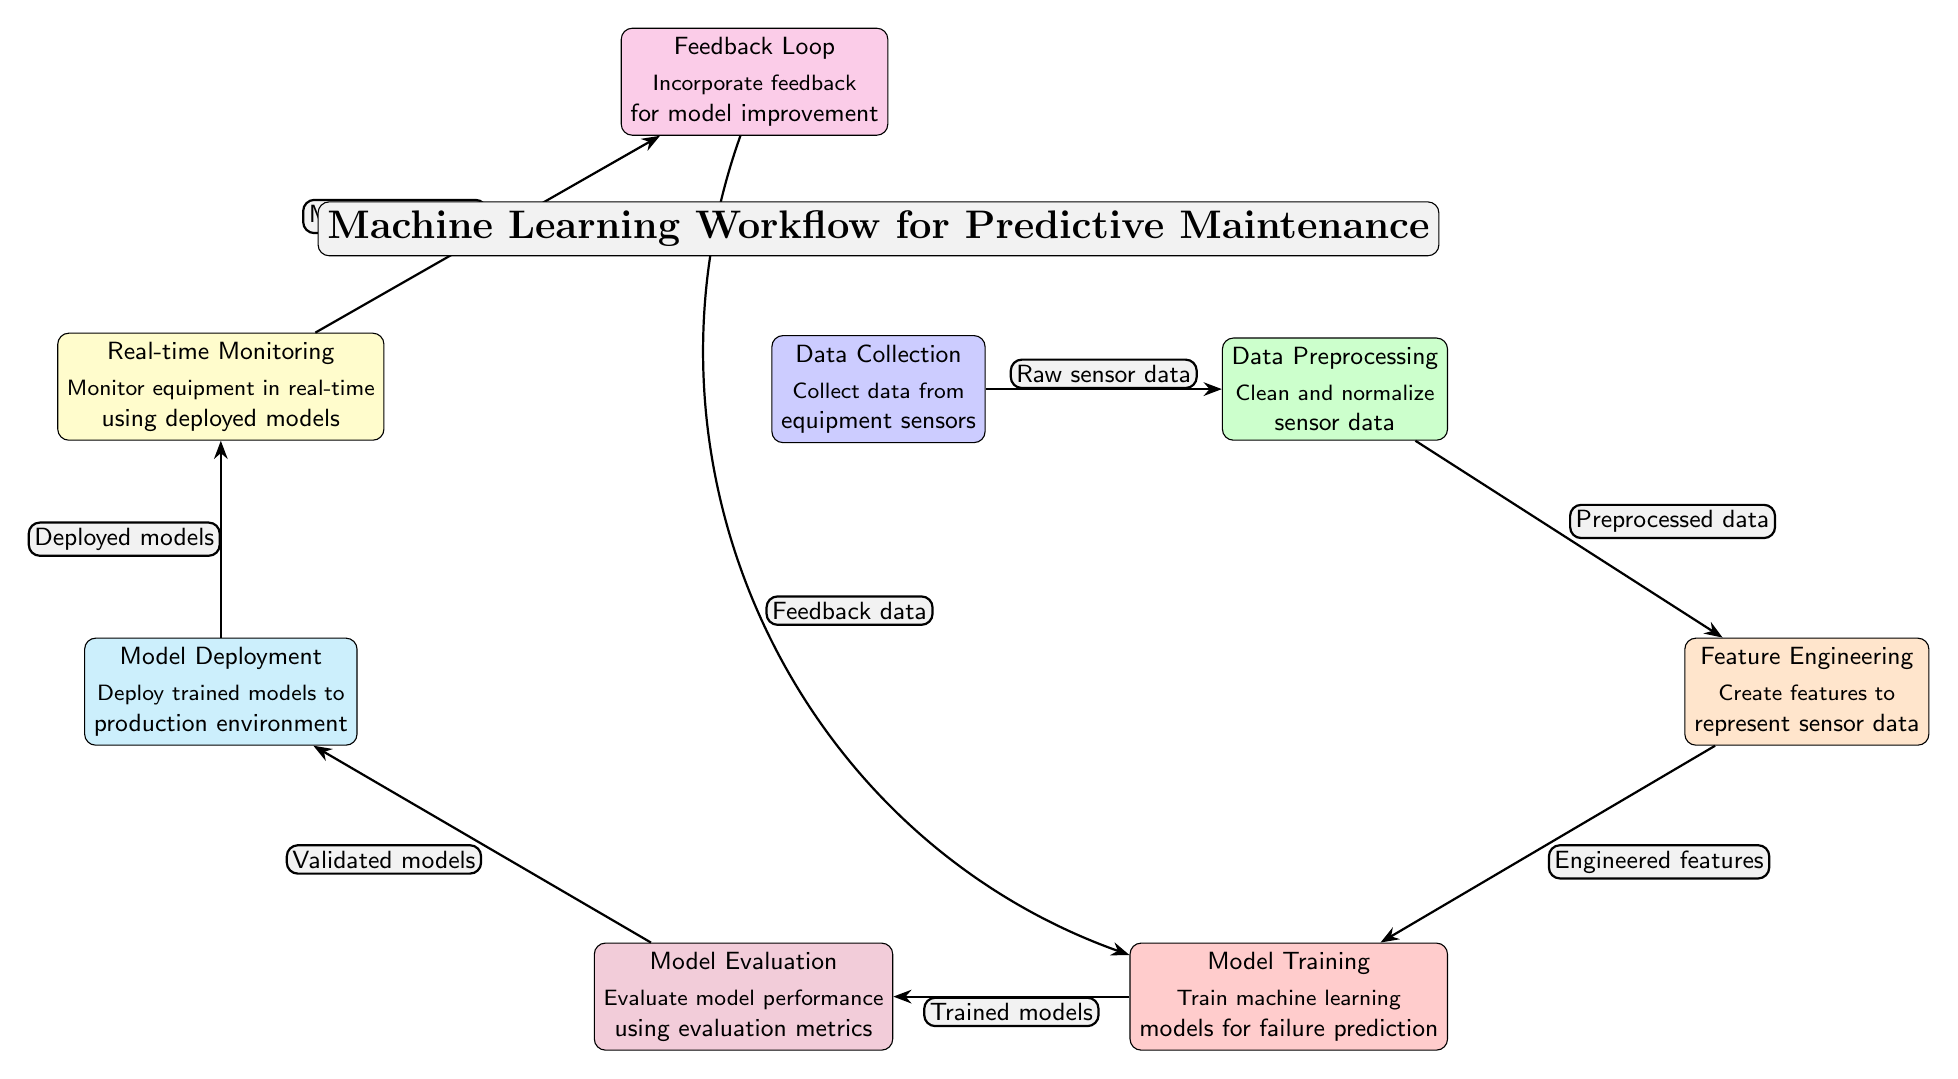What are the first data sources in the workflow? The workflows starts with data collection from equipment sensors, which is indicated in the diagram as the first node before any processing occurs.
Answer: Data Collection How many nodes are in the diagram? By counting all the unique nodes displayed in the diagram, we will find that there are seven distinct nodes contributing to the workflow.
Answer: Seven What type of data is used in the data preprocessing stage? The data preprocessing stage utilizes raw sensor data collected from the equipment, serving as its initial input before any cleaning or normalization is applied.
Answer: Raw sensor data Which node comes immediately after model evaluation? Following the model evaluation node in the sequence, the next step in the workflow is model deployment, where trained models are put into a production environment.
Answer: Model Deployment What is the purpose of the feedback loop? The feedback loop serves to incorporate feedback for model improvement, thereby allowing the system to adjust based on performance and new insights gained from monitoring data.
Answer: Incorporate feedback for model improvement What is the sixth node in the vertical workflow? The sixth node in the established vertical sequence of the workflow, counting from the top, is real-time monitoring, which focuses on operational oversight using deployed models.
Answer: Real-time Monitoring What type of models are produced during model training? During the model training phase, the output consists of trained models specifically designed for failure prediction, which can then be evaluated and deployed as part of the workflow.
Answer: Trained models How is data from real-time monitoring utilized? The real-time monitoring data is used to facilitate the feedback loop, which collects information to refine and improve the machine learning models based on actual performance during operation.
Answer: Monitoring data What do the edges between nodes represent? The edges in the diagram represent the flow of data through the different stages of the workflow, showing how each step is connected by the specific outputs and inputs that move from one node to the next.
Answer: The flow of data 